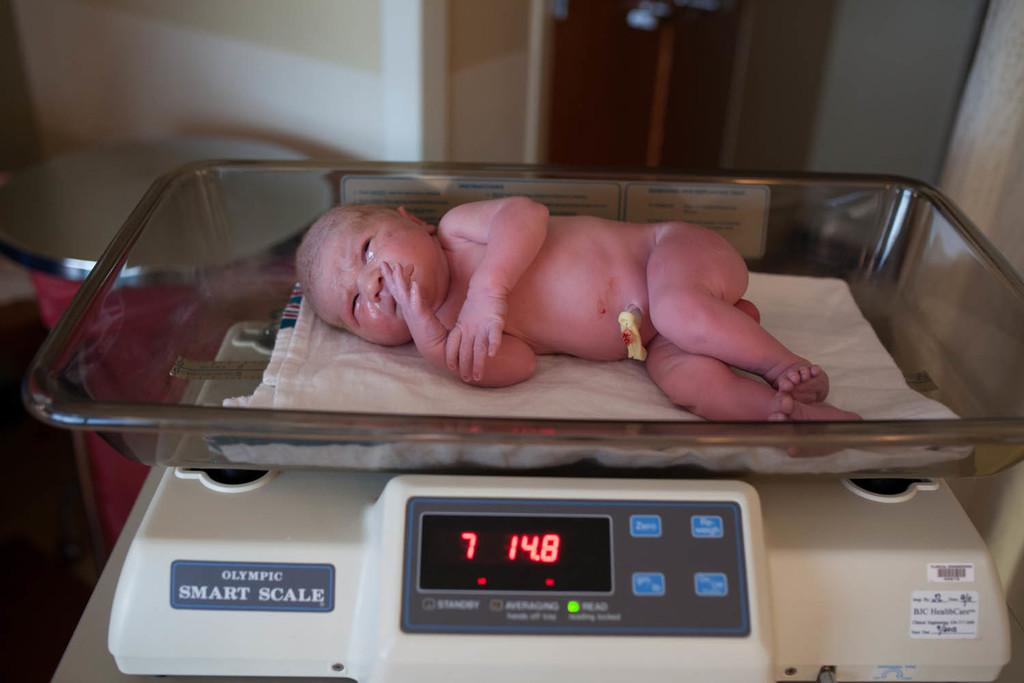What is the main subject of the image? The main subject of the image is a newborn baby. What is the baby doing in the image? The baby is laying on a white cloth on a weighing machine. What can be seen in the background of the image? There is a wall in the background of the image. Are there any additional items visible at the bottom of the image? Yes, there are stickers visible at the bottom of the image. What type of operation is being performed on the baby in the image? There is no operation being performed on the baby in the image; the baby is simply laying on a white cloth on a weighing machine. What type of badge is the baby wearing in the image? There is no badge visible on the baby in the image. 